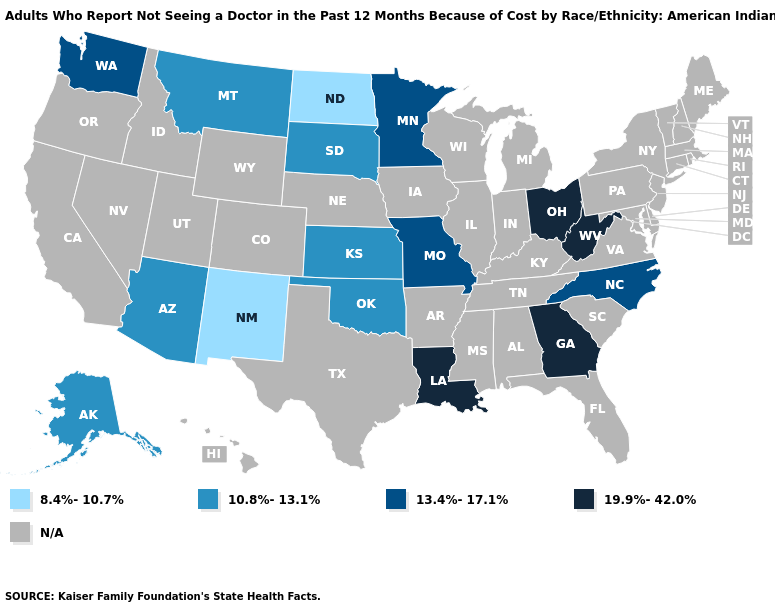Name the states that have a value in the range 13.4%-17.1%?
Write a very short answer. Minnesota, Missouri, North Carolina, Washington. Does the map have missing data?
Be succinct. Yes. What is the highest value in states that border West Virginia?
Quick response, please. 19.9%-42.0%. How many symbols are there in the legend?
Keep it brief. 5. What is the value of Nevada?
Short answer required. N/A. Name the states that have a value in the range 13.4%-17.1%?
Give a very brief answer. Minnesota, Missouri, North Carolina, Washington. Which states have the highest value in the USA?
Be succinct. Georgia, Louisiana, Ohio, West Virginia. What is the value of Wyoming?
Quick response, please. N/A. What is the highest value in states that border North Carolina?
Concise answer only. 19.9%-42.0%. Name the states that have a value in the range 10.8%-13.1%?
Short answer required. Alaska, Arizona, Kansas, Montana, Oklahoma, South Dakota. How many symbols are there in the legend?
Write a very short answer. 5. 